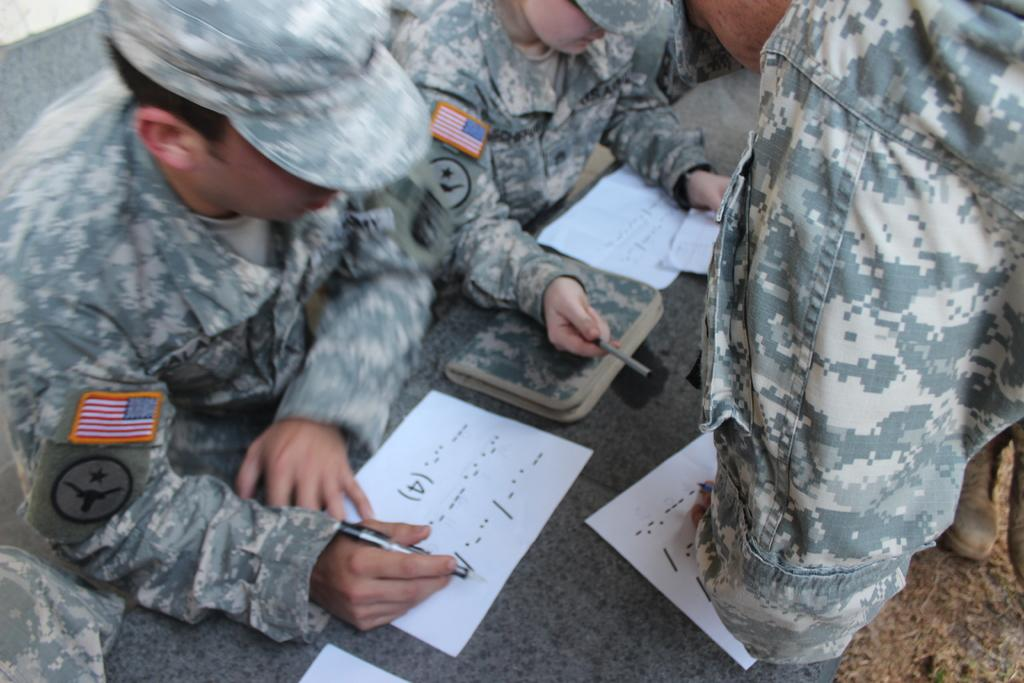How many people are in the image? There are many persons in the image. What are the persons doing in the image? The persons are around a table. What objects can be seen on the table? There are papers and books on the table. What type of bag can be seen in the image? There is no bag present in the image. Can you describe the yard where the persons are gathered in the image? There is no yard visible in the image; it only shows the persons around a table with papers and books. 